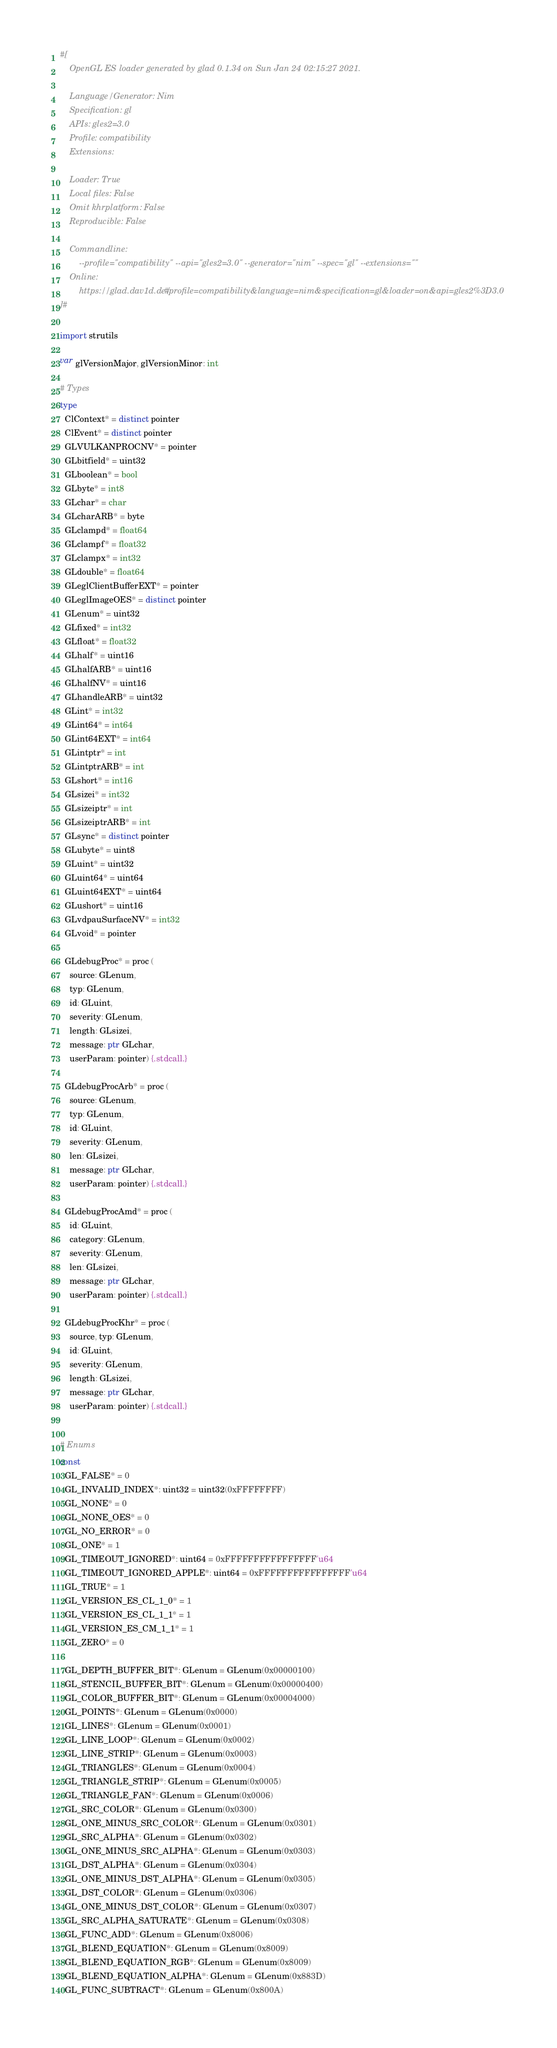<code> <loc_0><loc_0><loc_500><loc_500><_Nim_>#[
    OpenGL ES loader generated by glad 0.1.34 on Sun Jan 24 02:15:27 2021.

    Language/Generator: Nim
    Specification: gl
    APIs: gles2=3.0
    Profile: compatibility
    Extensions:
        
    Loader: True
    Local files: False
    Omit khrplatform: False
    Reproducible: False

    Commandline:
        --profile="compatibility" --api="gles2=3.0" --generator="nim" --spec="gl" --extensions=""
    Online:
        https://glad.dav1d.de/#profile=compatibility&language=nim&specification=gl&loader=on&api=gles2%3D3.0
]#

import strutils

var glVersionMajor, glVersionMinor: int

# Types
type
  ClContext* = distinct pointer
  ClEvent* = distinct pointer
  GLVULKANPROCNV* = pointer
  GLbitfield* = uint32
  GLboolean* = bool
  GLbyte* = int8
  GLchar* = char
  GLcharARB* = byte
  GLclampd* = float64
  GLclampf* = float32
  GLclampx* = int32
  GLdouble* = float64
  GLeglClientBufferEXT* = pointer
  GLeglImageOES* = distinct pointer
  GLenum* = uint32
  GLfixed* = int32
  GLfloat* = float32
  GLhalf* = uint16
  GLhalfARB* = uint16
  GLhalfNV* = uint16
  GLhandleARB* = uint32
  GLint* = int32
  GLint64* = int64
  GLint64EXT* = int64
  GLintptr* = int
  GLintptrARB* = int
  GLshort* = int16
  GLsizei* = int32
  GLsizeiptr* = int
  GLsizeiptrARB* = int
  GLsync* = distinct pointer
  GLubyte* = uint8
  GLuint* = uint32
  GLuint64* = uint64
  GLuint64EXT* = uint64
  GLushort* = uint16
  GLvdpauSurfaceNV* = int32
  GLvoid* = pointer

  GLdebugProc* = proc (
    source: GLenum,
    typ: GLenum,
    id: GLuint,
    severity: GLenum,
    length: GLsizei,
    message: ptr GLchar,
    userParam: pointer) {.stdcall.}

  GLdebugProcArb* = proc (
    source: GLenum,
    typ: GLenum,
    id: GLuint,
    severity: GLenum,
    len: GLsizei,
    message: ptr GLchar,
    userParam: pointer) {.stdcall.}

  GLdebugProcAmd* = proc (
    id: GLuint,
    category: GLenum,
    severity: GLenum,
    len: GLsizei,
    message: ptr GLchar,
    userParam: pointer) {.stdcall.}

  GLdebugProcKhr* = proc (
    source, typ: GLenum,
    id: GLuint,
    severity: GLenum,
    length: GLsizei,
    message: ptr GLchar,
    userParam: pointer) {.stdcall.}


# Enums
const
  GL_FALSE* = 0
  GL_INVALID_INDEX*: uint32 = uint32(0xFFFFFFFF)
  GL_NONE* = 0
  GL_NONE_OES* = 0
  GL_NO_ERROR* = 0
  GL_ONE* = 1
  GL_TIMEOUT_IGNORED*: uint64 = 0xFFFFFFFFFFFFFFFF'u64
  GL_TIMEOUT_IGNORED_APPLE*: uint64 = 0xFFFFFFFFFFFFFFFF'u64
  GL_TRUE* = 1
  GL_VERSION_ES_CL_1_0* = 1
  GL_VERSION_ES_CL_1_1* = 1
  GL_VERSION_ES_CM_1_1* = 1
  GL_ZERO* = 0

  GL_DEPTH_BUFFER_BIT*: GLenum = GLenum(0x00000100)
  GL_STENCIL_BUFFER_BIT*: GLenum = GLenum(0x00000400)
  GL_COLOR_BUFFER_BIT*: GLenum = GLenum(0x00004000)
  GL_POINTS*: GLenum = GLenum(0x0000)
  GL_LINES*: GLenum = GLenum(0x0001)
  GL_LINE_LOOP*: GLenum = GLenum(0x0002)
  GL_LINE_STRIP*: GLenum = GLenum(0x0003)
  GL_TRIANGLES*: GLenum = GLenum(0x0004)
  GL_TRIANGLE_STRIP*: GLenum = GLenum(0x0005)
  GL_TRIANGLE_FAN*: GLenum = GLenum(0x0006)
  GL_SRC_COLOR*: GLenum = GLenum(0x0300)
  GL_ONE_MINUS_SRC_COLOR*: GLenum = GLenum(0x0301)
  GL_SRC_ALPHA*: GLenum = GLenum(0x0302)
  GL_ONE_MINUS_SRC_ALPHA*: GLenum = GLenum(0x0303)
  GL_DST_ALPHA*: GLenum = GLenum(0x0304)
  GL_ONE_MINUS_DST_ALPHA*: GLenum = GLenum(0x0305)
  GL_DST_COLOR*: GLenum = GLenum(0x0306)
  GL_ONE_MINUS_DST_COLOR*: GLenum = GLenum(0x0307)
  GL_SRC_ALPHA_SATURATE*: GLenum = GLenum(0x0308)
  GL_FUNC_ADD*: GLenum = GLenum(0x8006)
  GL_BLEND_EQUATION*: GLenum = GLenum(0x8009)
  GL_BLEND_EQUATION_RGB*: GLenum = GLenum(0x8009)
  GL_BLEND_EQUATION_ALPHA*: GLenum = GLenum(0x883D)
  GL_FUNC_SUBTRACT*: GLenum = GLenum(0x800A)</code> 